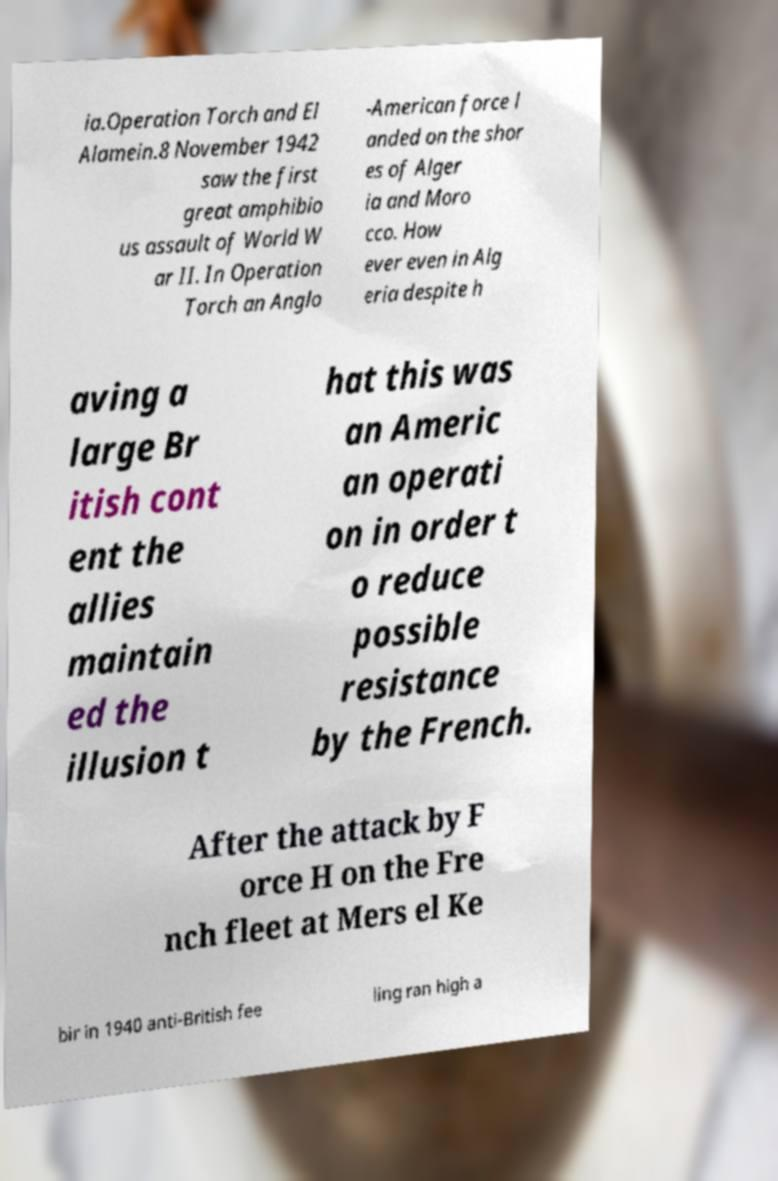I need the written content from this picture converted into text. Can you do that? ia.Operation Torch and El Alamein.8 November 1942 saw the first great amphibio us assault of World W ar II. In Operation Torch an Anglo -American force l anded on the shor es of Alger ia and Moro cco. How ever even in Alg eria despite h aving a large Br itish cont ent the allies maintain ed the illusion t hat this was an Americ an operati on in order t o reduce possible resistance by the French. After the attack by F orce H on the Fre nch fleet at Mers el Ke bir in 1940 anti-British fee ling ran high a 